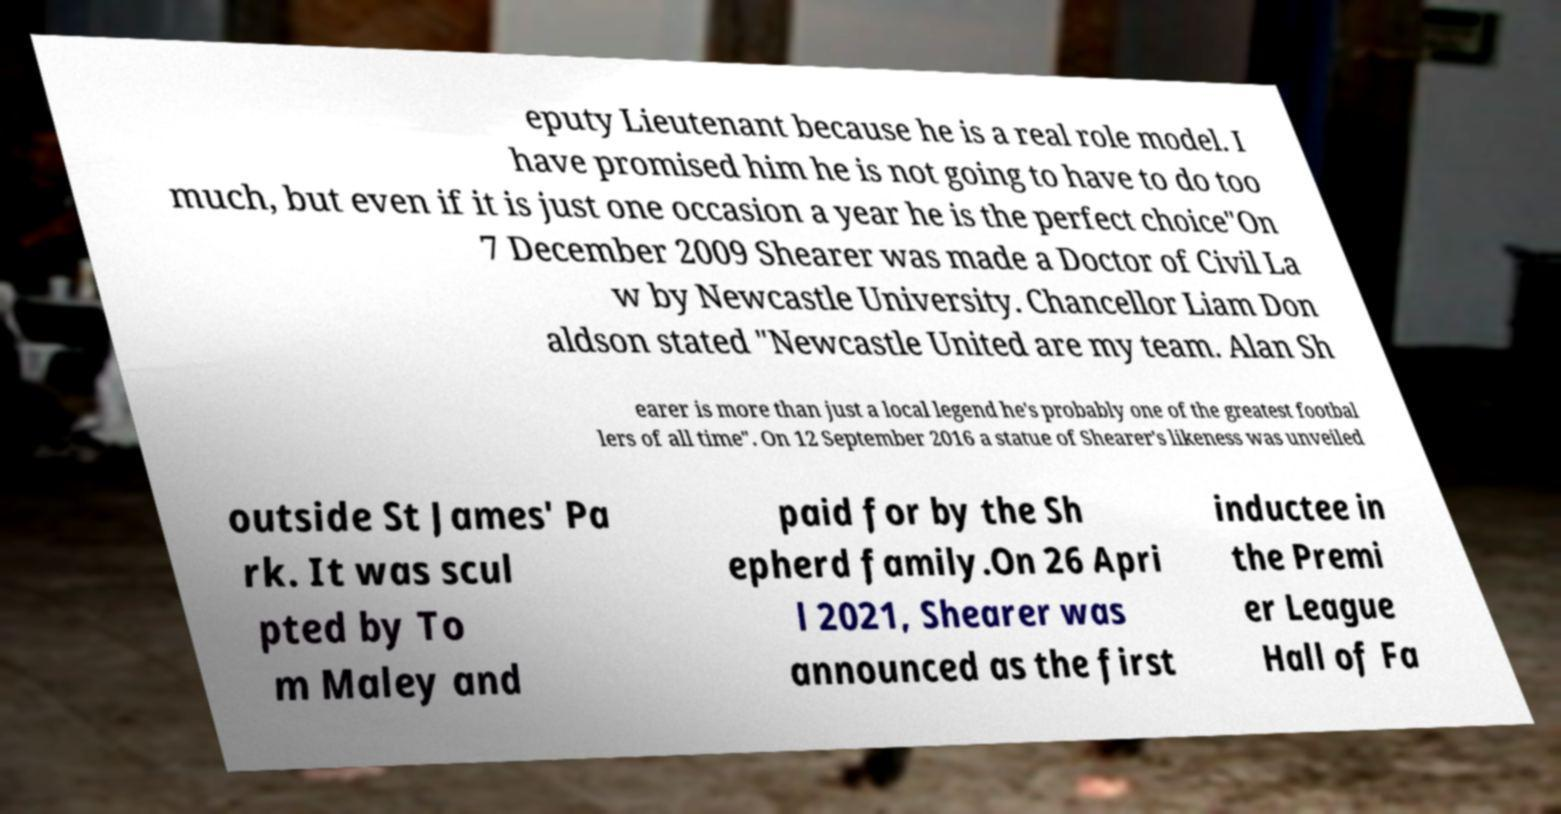For documentation purposes, I need the text within this image transcribed. Could you provide that? eputy Lieutenant because he is a real role model. I have promised him he is not going to have to do too much, but even if it is just one occasion a year he is the perfect choice"On 7 December 2009 Shearer was made a Doctor of Civil La w by Newcastle University. Chancellor Liam Don aldson stated "Newcastle United are my team. Alan Sh earer is more than just a local legend he's probably one of the greatest footbal lers of all time". On 12 September 2016 a statue of Shearer's likeness was unveiled outside St James' Pa rk. It was scul pted by To m Maley and paid for by the Sh epherd family.On 26 Apri l 2021, Shearer was announced as the first inductee in the Premi er League Hall of Fa 